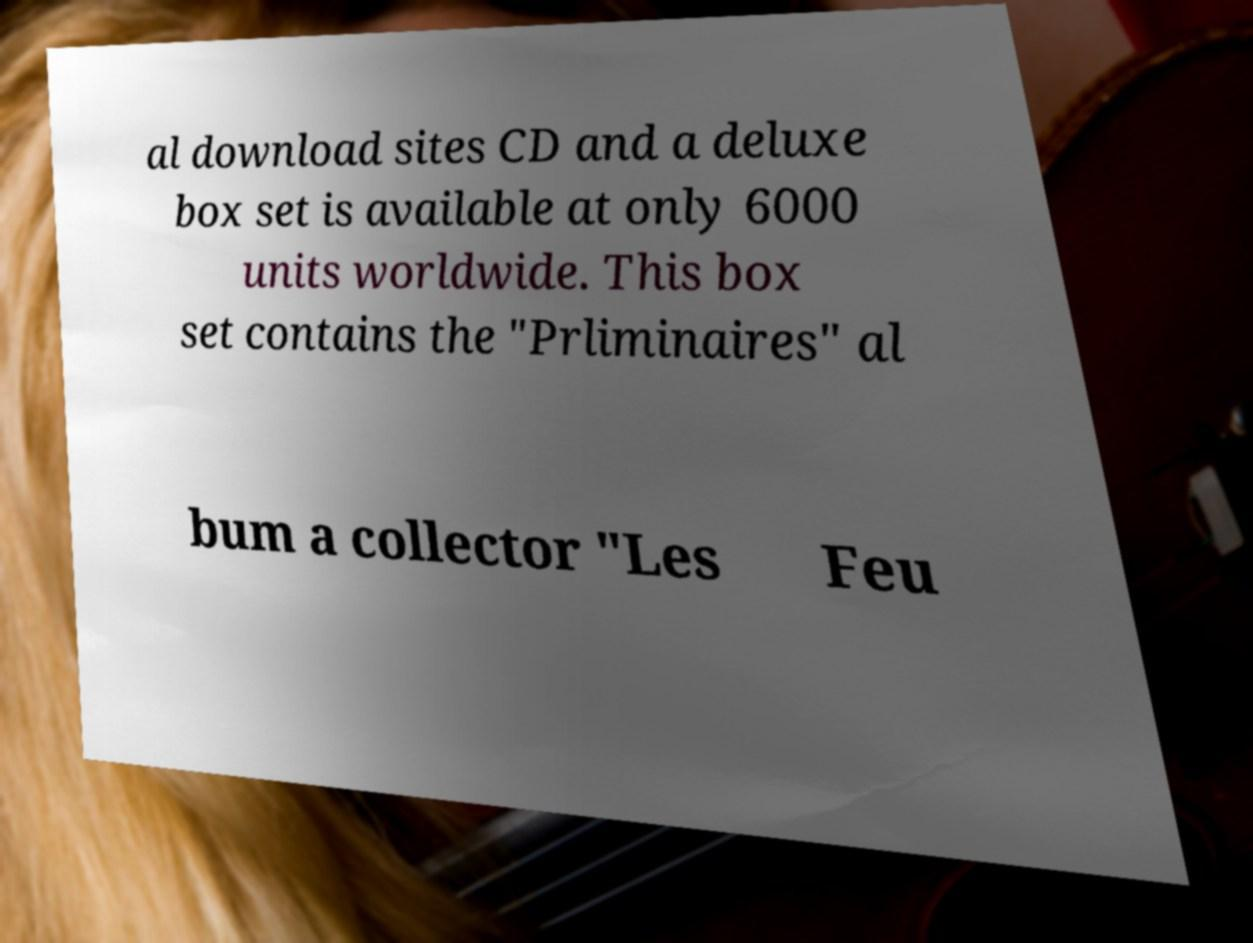What messages or text are displayed in this image? I need them in a readable, typed format. al download sites CD and a deluxe box set is available at only 6000 units worldwide. This box set contains the "Prliminaires" al bum a collector "Les Feu 